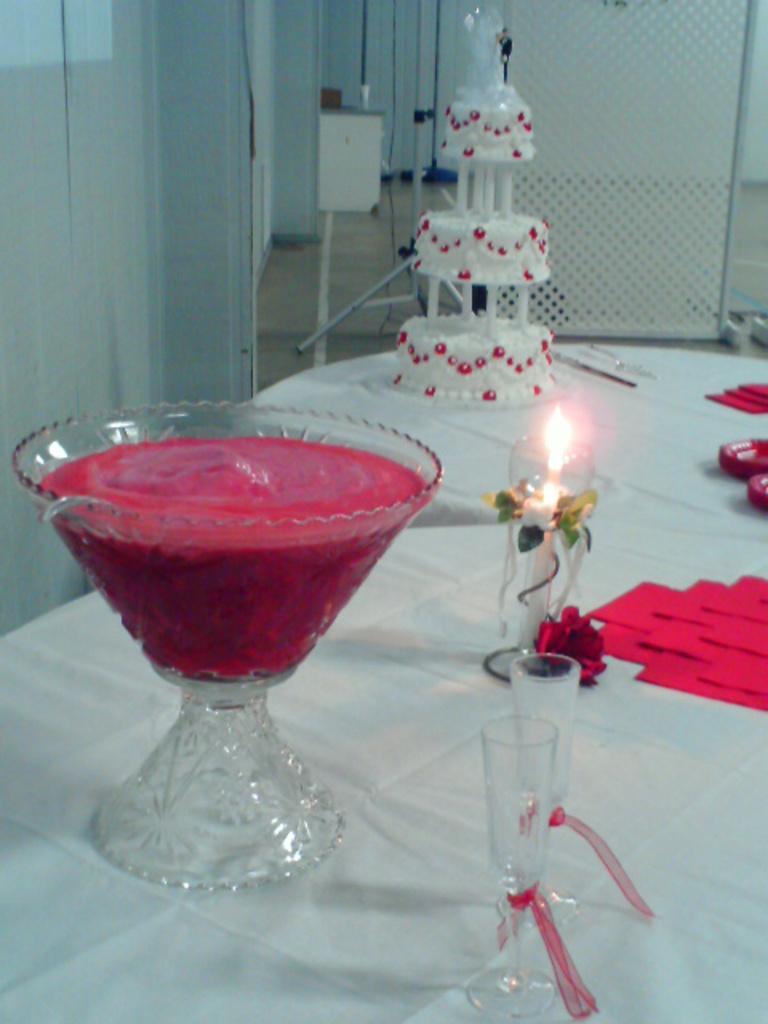Can you describe this image briefly? In this image I can see the glass bowl with liquid, cake, candle, glasses and flowers. These are on the table. To the side I can see few more objects. In the background I can see the curtain. 